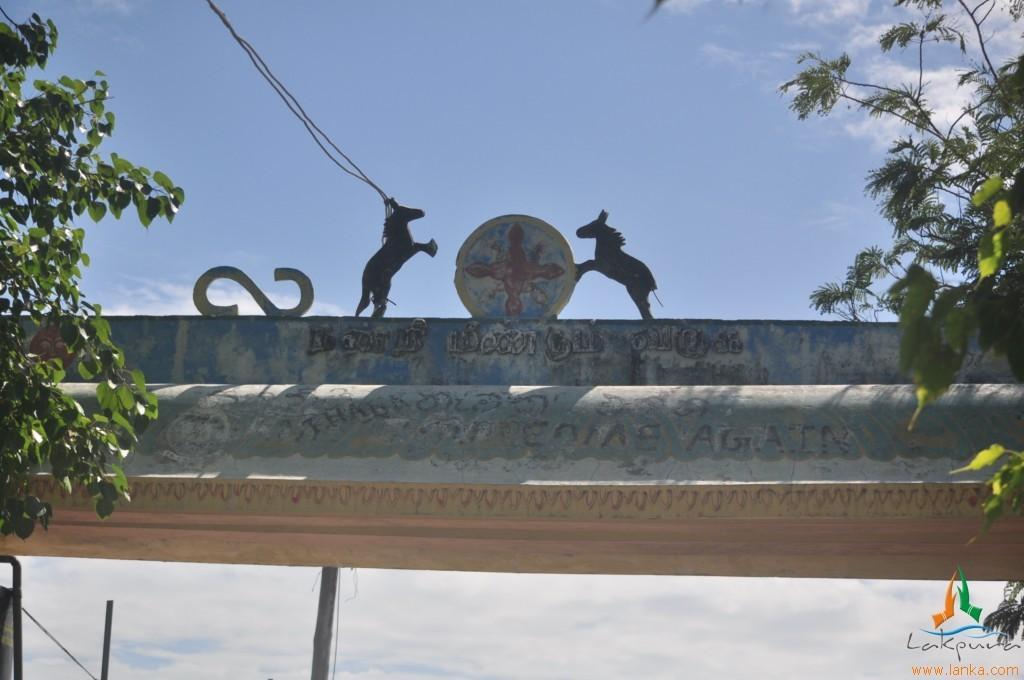Please provide a concise description of this image. In the center of the image there is a arch on which there are depictions of horses and there is some text. To the both sides of the image there are trees. In the background of the image there is sky. At the bottom of the image there is some text. 